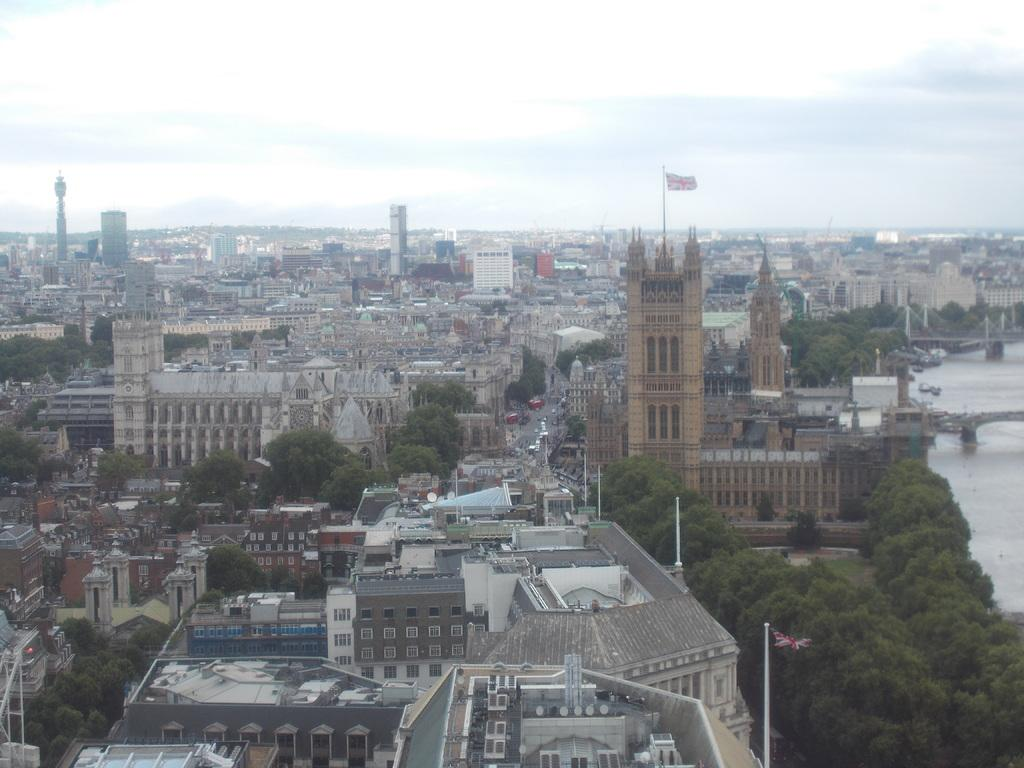What is located in the center of the image? There are buildings and trees in the center of the image. What can be seen at the top of the image? The sky is visible at the top of the image. How does the friction between the buildings and trees affect the eye in the image? There is no mention of friction, eye, or any interaction between the buildings and trees in the image. 